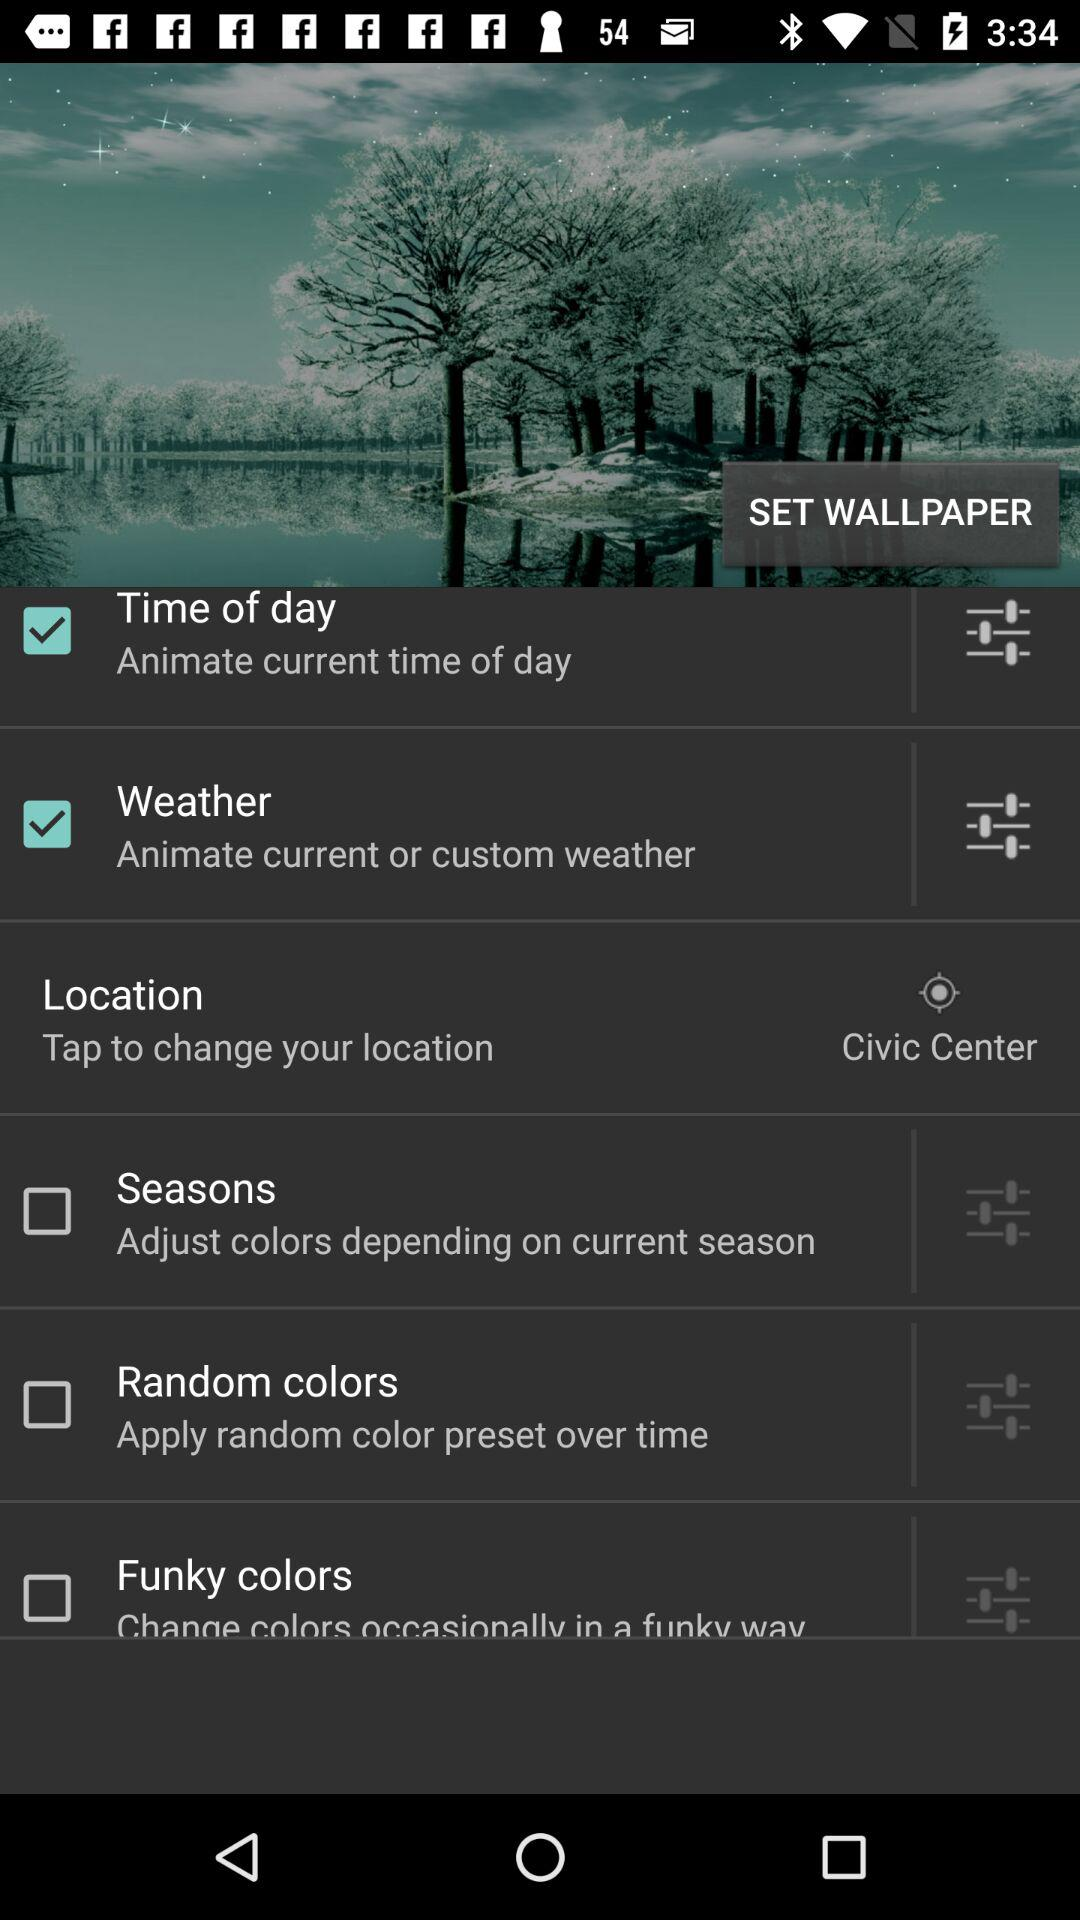What is the current location? The current location is the Civic Center. 